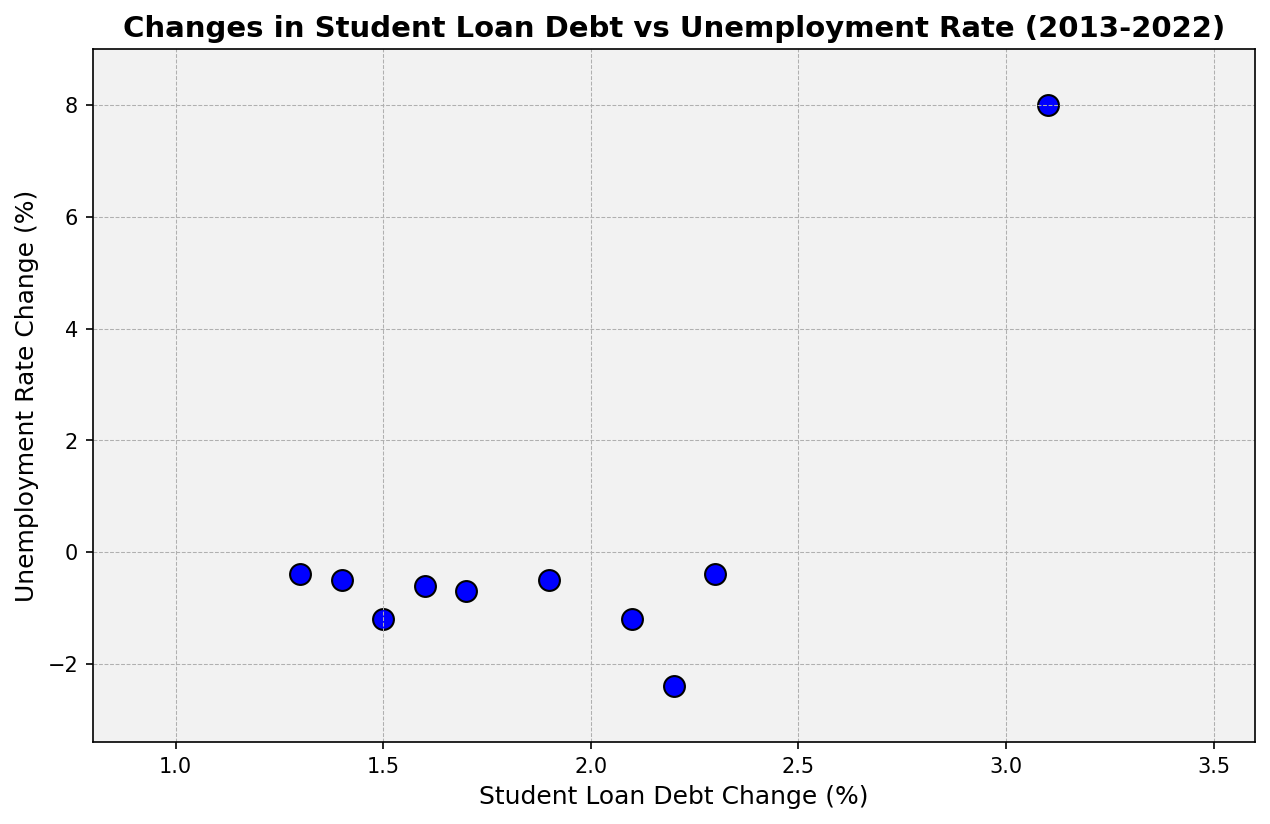What year shows the highest change in student loan debt? Look at the x-axis to find the highest student loan debt change point. The highest point on the x-axis is 3.1% in the year 2020.
Answer: 2020 Was there a year when the unemployment rate change was positive? If so, which year? Identify which years have data points above the zero line on the y-axis, indicating positive unemployment rate changes. The year 2020 has a positive change in the unemployment rate (8.0%).
Answer: 2020 In which year did both student loan debt and unemployment rate decrease? Look for data points where both the x and y values are negative. For instance, in 2021, student loan debt change is 2.2% and unemployment rate change is -2.4%, meaning only unemployment rate decreased while student loan debt increased.
Answer: None What is the average change in student loan debt over the first three years (2013-2015)? Calculate the average of student loan debt changes for 2013, 2014, and 2015. The values are 1.7%, 2.1%, and 1.9%. The sum is 5.7%, and the average is 5.7 / 3 = 1.9%.
Answer: 1.9% How does the student loan debt change in 2020 compare to the change in 2019? Compare the student loan debt changes: 3.1% in 2020 and 1.3% in 2019. 3.1 is greater than 1.3.
Answer: 2020 > 2019 In which year did the student loan debt change and the unemployment rate change both have the least impact (in absolute terms)? Find the data point with the lowest absolute values in both StudentLoanDebtChange and UnemploymentRateChange columns. The year 2019 has 1.3 and -0.4, which together are the smallest in absolute value.
Answer: 2019 Was the year 2018's change in the unemployment rate more or less than in 2022? Compare the unemployment rate changes for both years: In 2018, it was -0.5%; in 2022, it was -1.2%. Therefore, -0.5 is greater than -1.2.
Answer: Less Identify the point where student loan debt change is below 1.6% and unemployment rate change is positive or zero? Look for data points where student loan debt change is below 1.6% and unemployment rate change is zero or greater. In 2020, the student loan debt change is 3.1%, so no such point exists where debt change is below 1.6% and unemployment rate change is positive.
Answer: None How did the unemployment rate change in 2016 compared to 2017? Compare the unemployment rate changes: -0.4% in 2016 and -0.6% in 2017. -0.4 is greater than -0.6.
Answer: 2016 > 2017 What trend can you observe in student loan debt change from 2014 to 2019? Examine the data points from 2014 to 2019. The values are 2.1%, 1.9%, 2.3%, 1.6%, 1.4%, and 1.3%. The trend shows a general decrease over these years.
Answer: Decreasing 